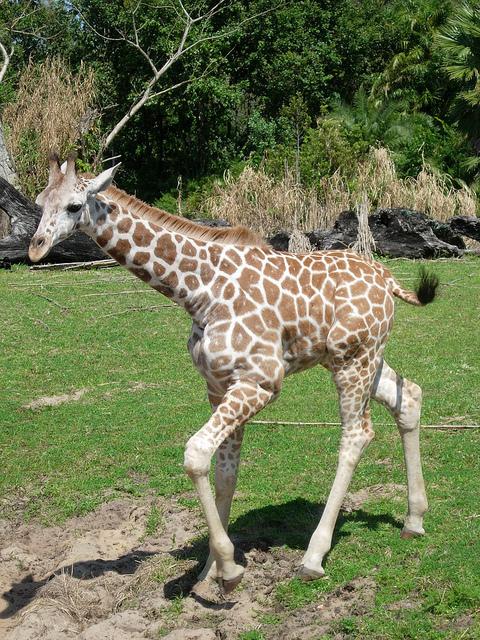How many legs does the giraffe have?
Concise answer only. 4. Is the giraffe moving or standing still?
Write a very short answer. Moving. Does this giraffe look full grown?
Write a very short answer. No. 